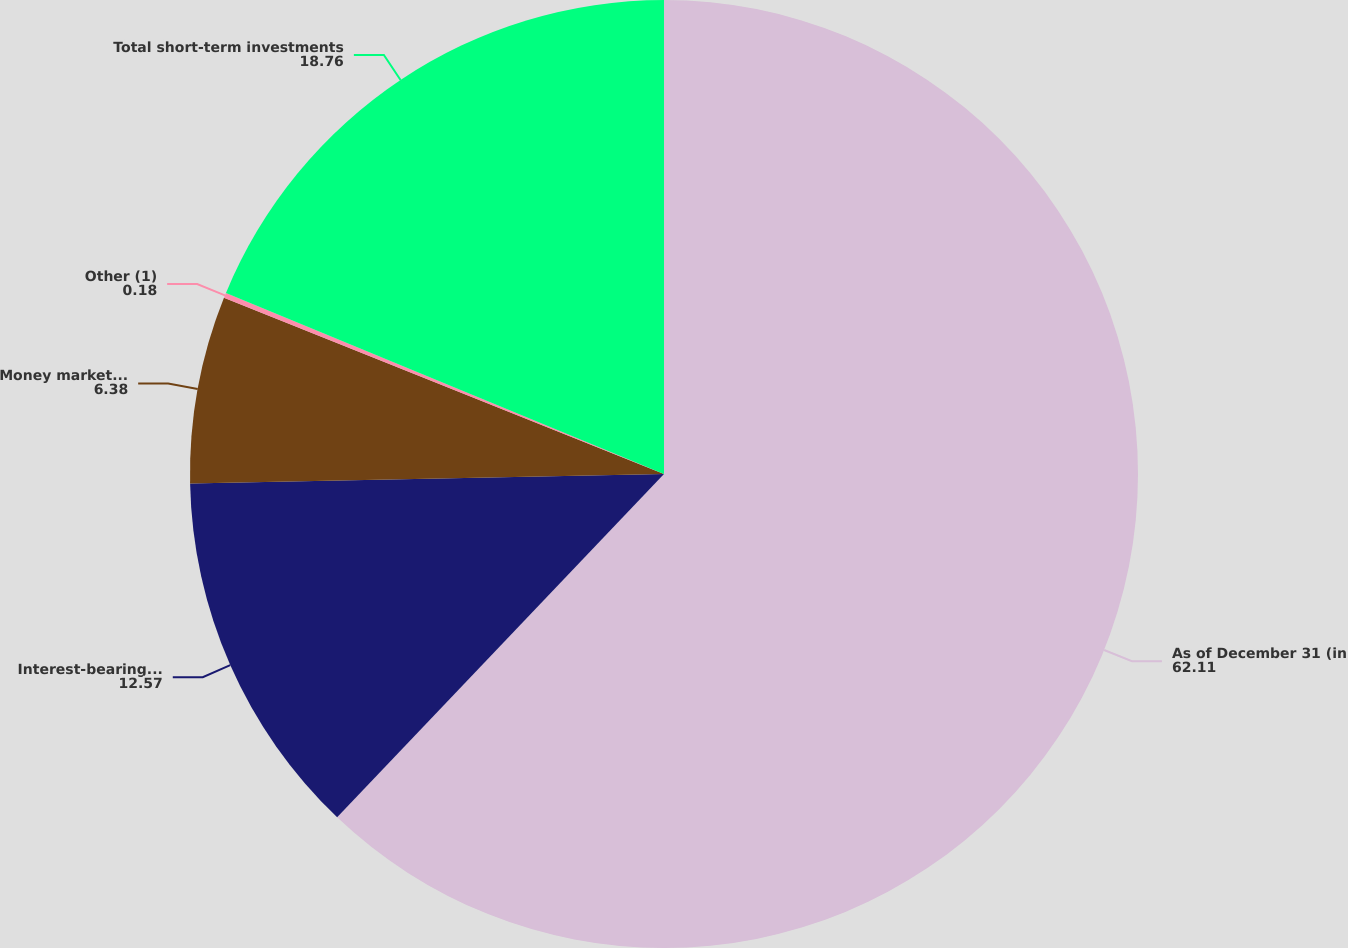Convert chart. <chart><loc_0><loc_0><loc_500><loc_500><pie_chart><fcel>As of December 31 (in<fcel>Interest-bearing deposits at<fcel>Money market mutual funds<fcel>Other (1)<fcel>Total short-term investments<nl><fcel>62.11%<fcel>12.57%<fcel>6.38%<fcel>0.18%<fcel>18.76%<nl></chart> 